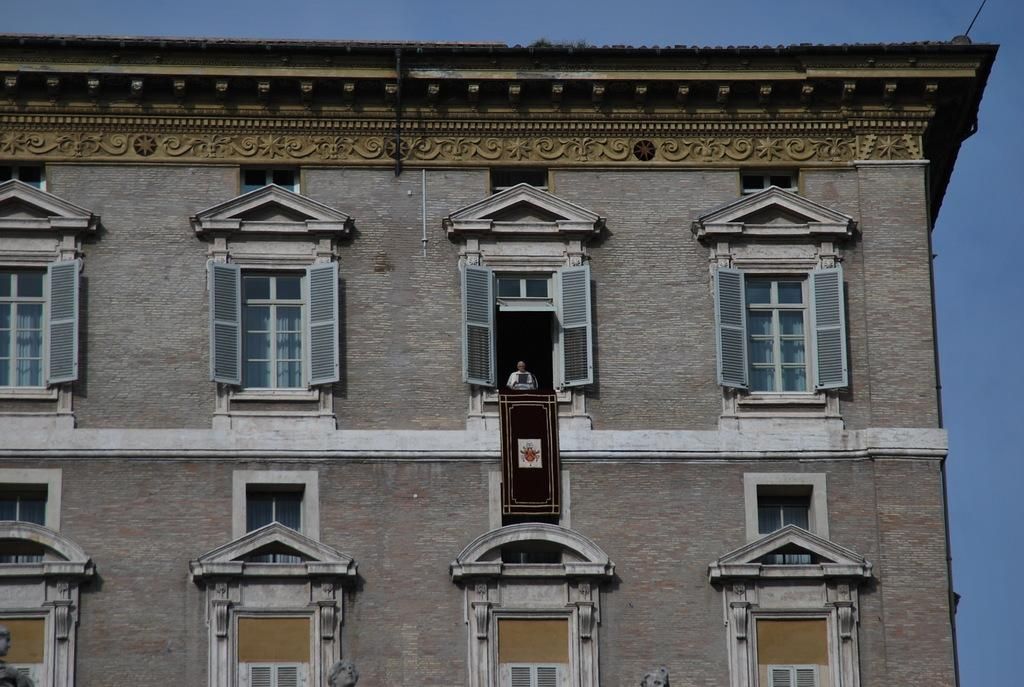What is the main structure in the image? There is a building in the image. What feature can be seen on the building? The building has windows. What is visible at the top of the image? The sky is visible at the top of the image. Can you describe the person in the image? There is a person visible in front of a window in the image. How does the person in the image grade the ocean's performance? There is no ocean present in the image, and therefore no performance to grade. 